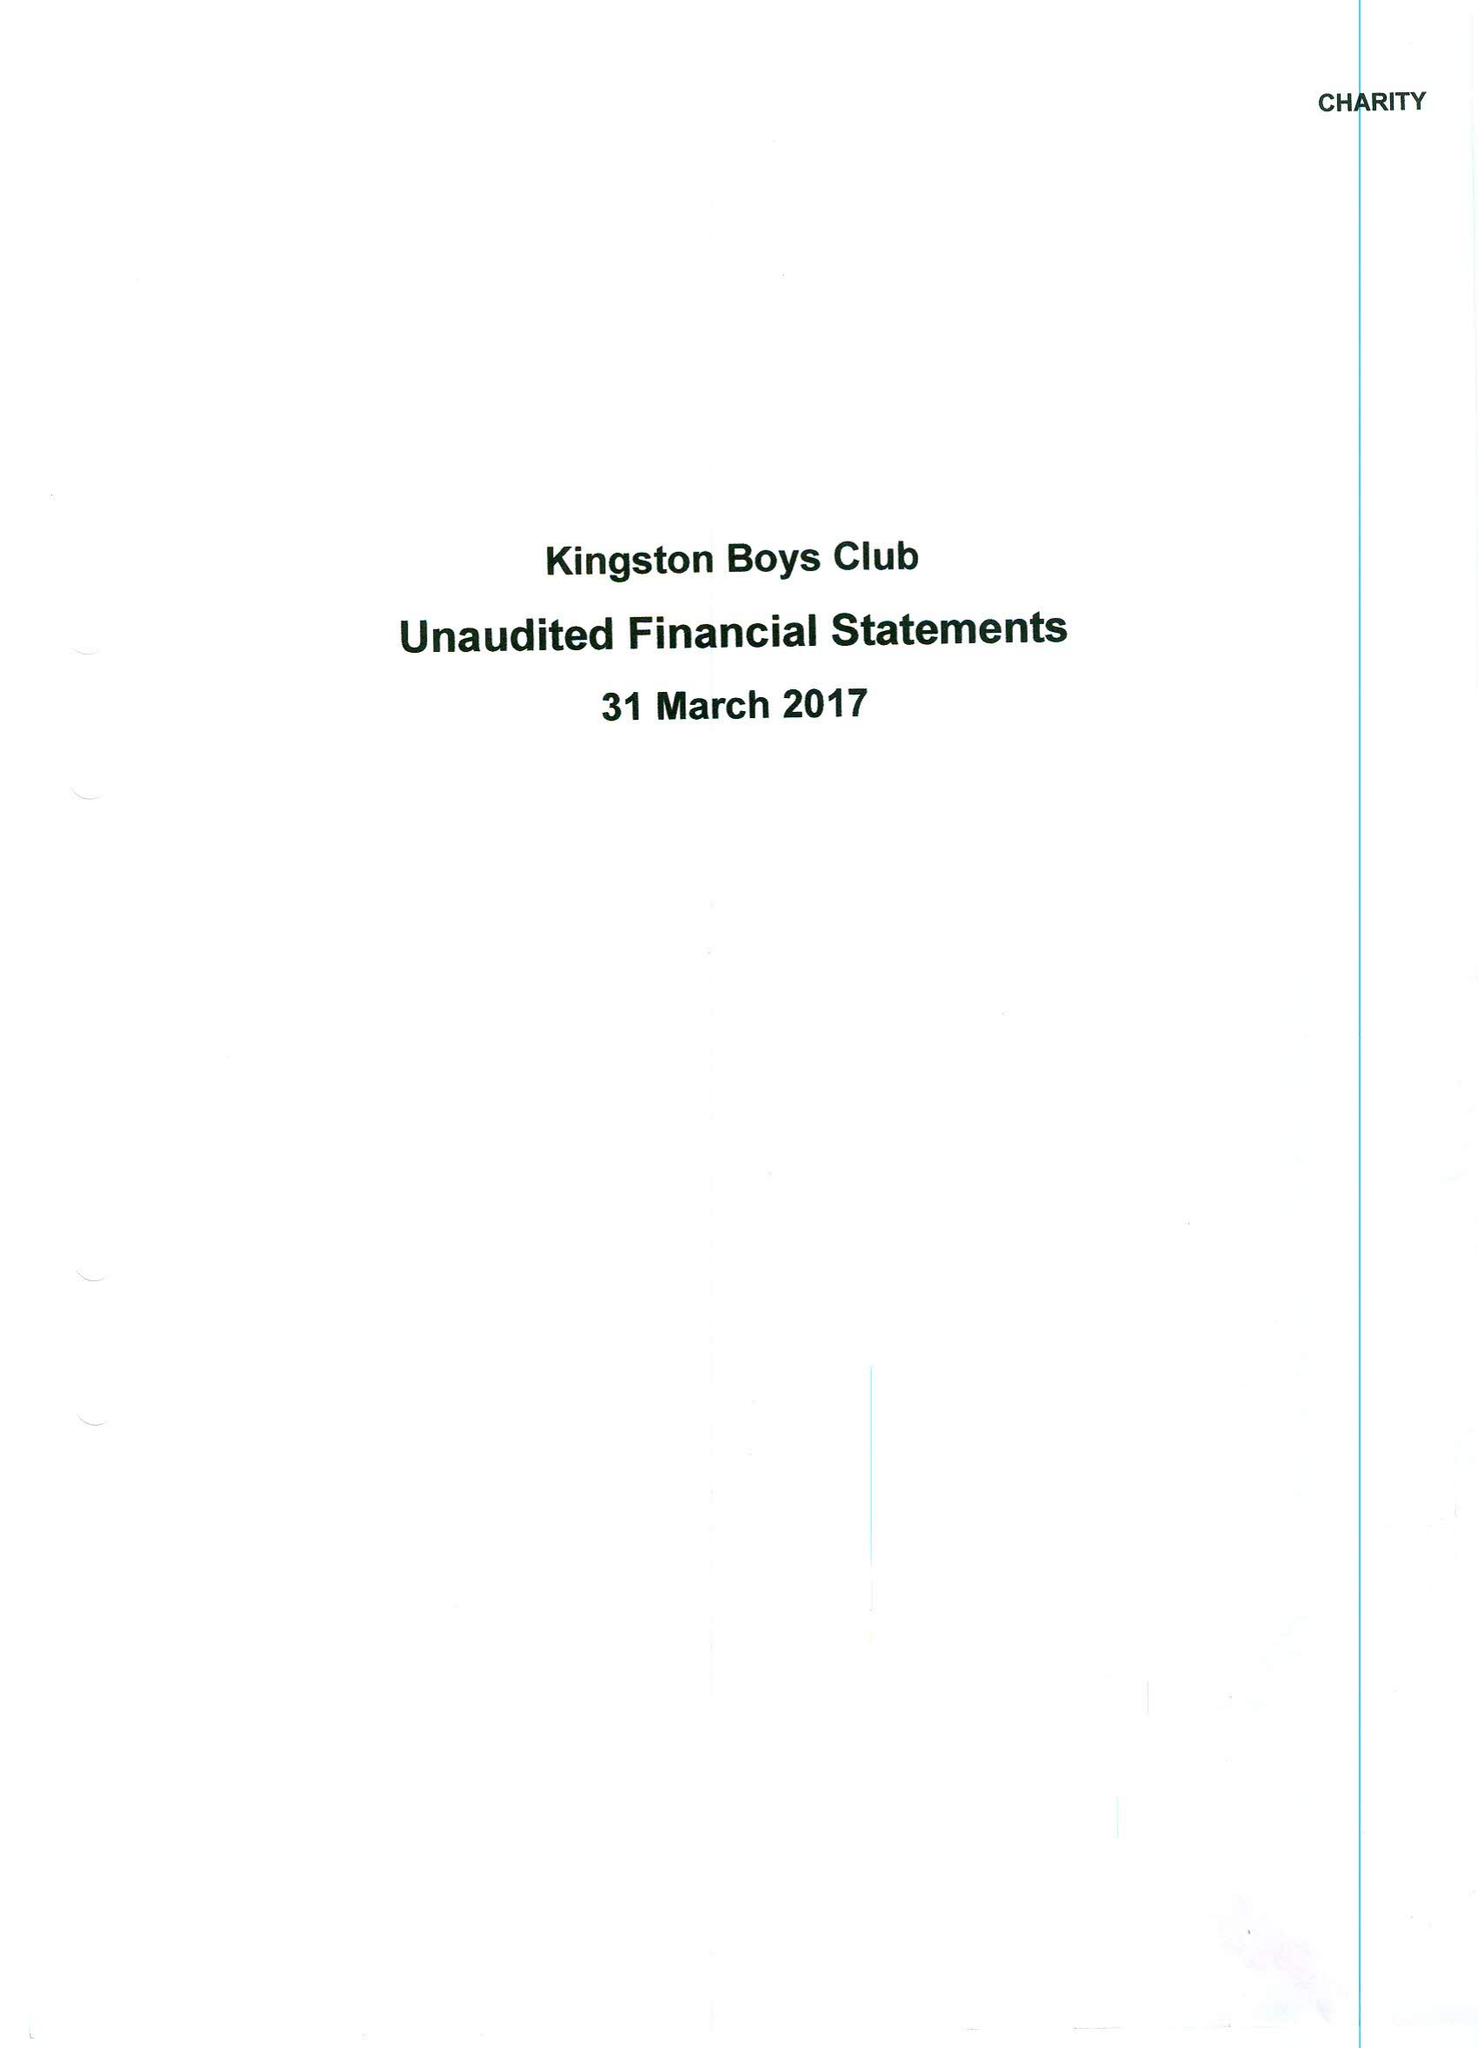What is the value for the report_date?
Answer the question using a single word or phrase. 2017-03-31 